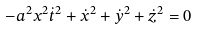Convert formula to latex. <formula><loc_0><loc_0><loc_500><loc_500>- a ^ { 2 } x ^ { 2 } { \dot { t } } ^ { 2 } + { \dot { x } } ^ { 2 } + { \dot { y } } ^ { 2 } + { \dot { z } } ^ { 2 } = 0</formula> 